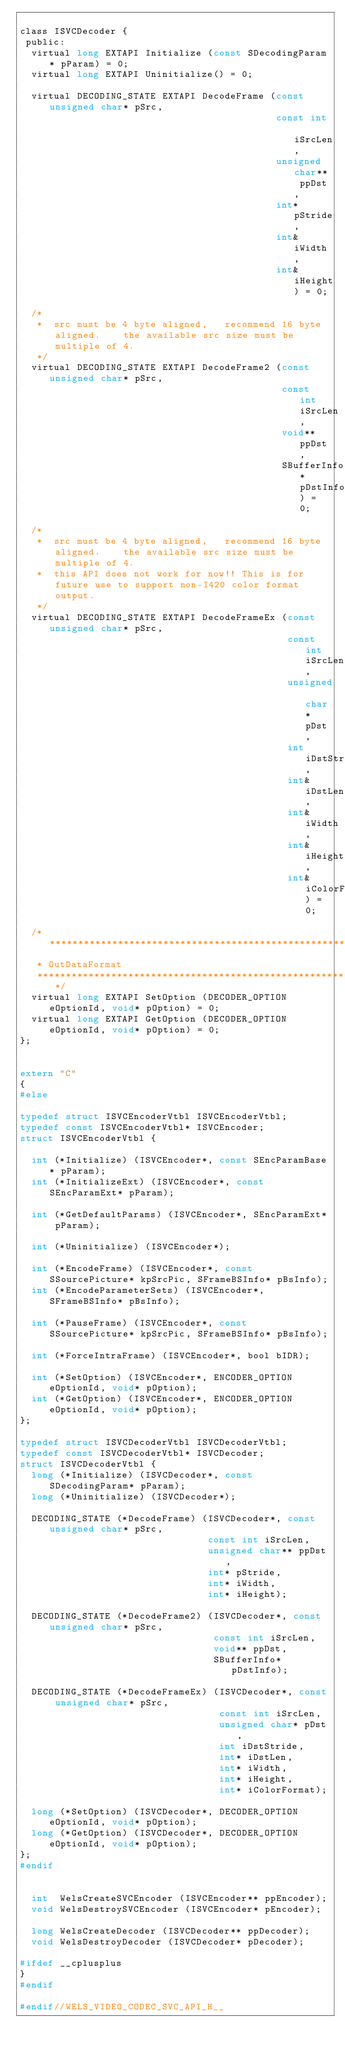<code> <loc_0><loc_0><loc_500><loc_500><_C_>
class ISVCDecoder {
 public:
  virtual long EXTAPI Initialize (const SDecodingParam* pParam) = 0;
  virtual long EXTAPI Uninitialize() = 0;

  virtual DECODING_STATE EXTAPI DecodeFrame (const unsigned char* pSrc,
                                             const int iSrcLen,
                                             unsigned char** ppDst,
                                             int* pStride,
                                             int& iWidth,
                                             int& iHeight) = 0;

  /*
   *  src must be 4 byte aligned,   recommend 16 byte aligned.    the available src size must be multiple of 4.
   */
  virtual DECODING_STATE EXTAPI DecodeFrame2 (const unsigned char* pSrc,
                                              const int iSrcLen,
                                              void** ppDst,
                                              SBufferInfo* pDstInfo) = 0;

  /*
   *  src must be 4 byte aligned,   recommend 16 byte aligned.    the available src size must be multiple of 4.
   *  this API does not work for now!! This is for future use to support non-I420 color format output.
   */
  virtual DECODING_STATE EXTAPI DecodeFrameEx (const unsigned char* pSrc,
                                               const int iSrcLen,
                                               unsigned char* pDst,
                                               int iDstStride,
                                               int& iDstLen,
                                               int& iWidth,
                                               int& iHeight,
                                               int& iColorFormat) = 0;

  /*************************************************************************
   * OutDataFormat
   *************************************************************************/
  virtual long EXTAPI SetOption (DECODER_OPTION eOptionId, void* pOption) = 0;
  virtual long EXTAPI GetOption (DECODER_OPTION eOptionId, void* pOption) = 0;
};


extern "C"
{
#else

typedef struct ISVCEncoderVtbl ISVCEncoderVtbl;
typedef const ISVCEncoderVtbl* ISVCEncoder;
struct ISVCEncoderVtbl {

  int (*Initialize) (ISVCEncoder*, const SEncParamBase* pParam);
  int (*InitializeExt) (ISVCEncoder*, const SEncParamExt* pParam);

  int (*GetDefaultParams) (ISVCEncoder*, SEncParamExt* pParam);

  int (*Uninitialize) (ISVCEncoder*);

  int (*EncodeFrame) (ISVCEncoder*, const SSourcePicture* kpSrcPic, SFrameBSInfo* pBsInfo);
  int (*EncodeParameterSets) (ISVCEncoder*, SFrameBSInfo* pBsInfo);

  int (*PauseFrame) (ISVCEncoder*, const SSourcePicture* kpSrcPic, SFrameBSInfo* pBsInfo);

  int (*ForceIntraFrame) (ISVCEncoder*, bool bIDR);

  int (*SetOption) (ISVCEncoder*, ENCODER_OPTION eOptionId, void* pOption);
  int (*GetOption) (ISVCEncoder*, ENCODER_OPTION eOptionId, void* pOption);
};

typedef struct ISVCDecoderVtbl ISVCDecoderVtbl;
typedef const ISVCDecoderVtbl* ISVCDecoder;
struct ISVCDecoderVtbl {
  long (*Initialize) (ISVCDecoder*, const SDecodingParam* pParam);
  long (*Uninitialize) (ISVCDecoder*);

  DECODING_STATE (*DecodeFrame) (ISVCDecoder*, const unsigned char* pSrc,
                                 const int iSrcLen,
                                 unsigned char** ppDst,
                                 int* pStride,
                                 int* iWidth,
                                 int* iHeight);

  DECODING_STATE (*DecodeFrame2) (ISVCDecoder*, const unsigned char* pSrc,
                                  const int iSrcLen,
                                  void** ppDst,
                                  SBufferInfo* pDstInfo);

  DECODING_STATE (*DecodeFrameEx) (ISVCDecoder*, const unsigned char* pSrc,
                                   const int iSrcLen,
                                   unsigned char* pDst,
                                   int iDstStride,
                                   int* iDstLen,
                                   int* iWidth,
                                   int* iHeight,
                                   int* iColorFormat);

  long (*SetOption) (ISVCDecoder*, DECODER_OPTION eOptionId, void* pOption);
  long (*GetOption) (ISVCDecoder*, DECODER_OPTION eOptionId, void* pOption);
};
#endif


  int  WelsCreateSVCEncoder (ISVCEncoder** ppEncoder);
  void WelsDestroySVCEncoder (ISVCEncoder* pEncoder);

  long WelsCreateDecoder (ISVCDecoder** ppDecoder);
  void WelsDestroyDecoder (ISVCDecoder* pDecoder);

#ifdef __cplusplus
}
#endif

#endif//WELS_VIDEO_CODEC_SVC_API_H__
</code> 